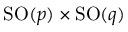<formula> <loc_0><loc_0><loc_500><loc_500>S O ( p ) \times S O ( q )</formula> 